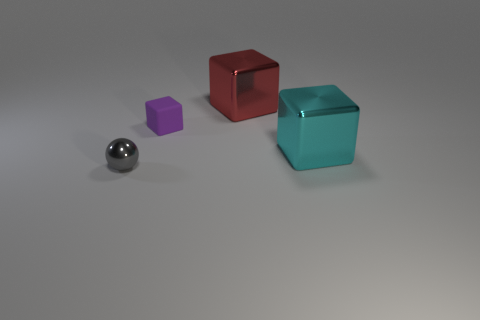The other block that is made of the same material as the red cube is what size?
Offer a very short reply. Large. How many small things are cubes or purple matte objects?
Ensure brevity in your answer.  1. There is a block that is to the right of the metallic block behind the tiny thing that is right of the gray thing; what size is it?
Keep it short and to the point. Large. How many matte balls have the same size as the rubber thing?
Provide a succinct answer. 0. What number of objects are either large red metal things or things in front of the rubber cube?
Give a very brief answer. 3. The small gray thing is what shape?
Give a very brief answer. Sphere. Is the matte object the same color as the shiny sphere?
Provide a short and direct response. No. There is a rubber thing that is the same size as the ball; what is its color?
Make the answer very short. Purple. What number of purple things are small metal balls or tiny rubber cubes?
Provide a short and direct response. 1. Is the number of balls greater than the number of yellow matte things?
Keep it short and to the point. Yes. 